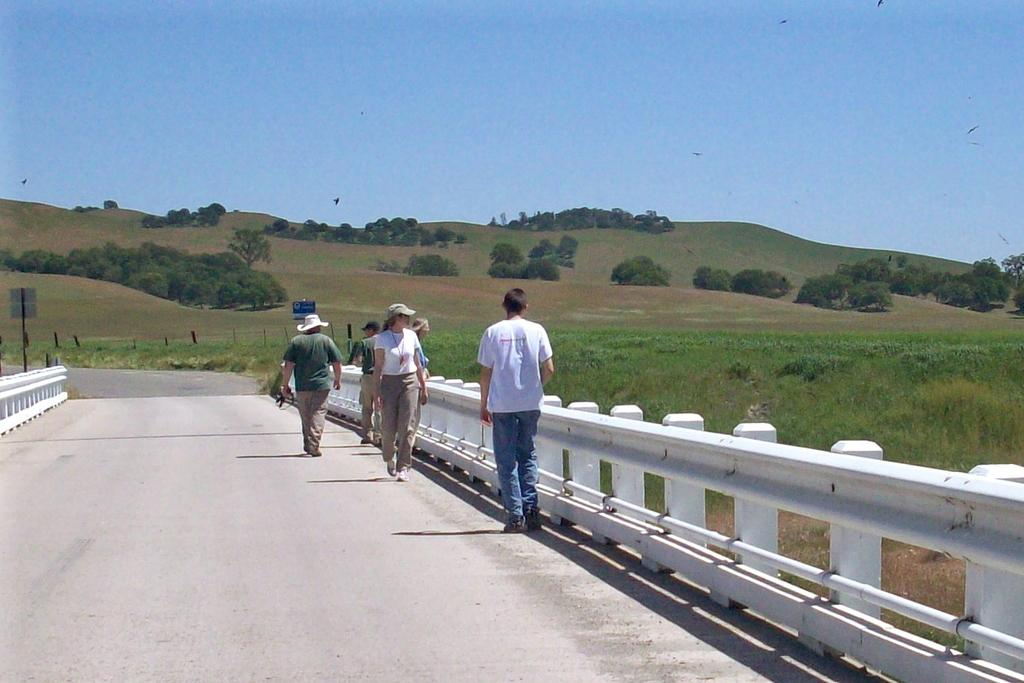What can be seen on the bridge in the image? There are people on the bridge in the image. What type of vegetation is visible in the background of the image? There are trees in the background of the image. What else can be seen in the background of the image? The sky is visible in the background of the image. What color is the eye of the person on the bridge in the image? There is no eye visible in the image; it is a photograph of people on a bridge, not a close-up of a person's face. Can you tell me how many berries are on the trees in the background of the image? There are no berries visible in the image; it only shows trees in the background. 